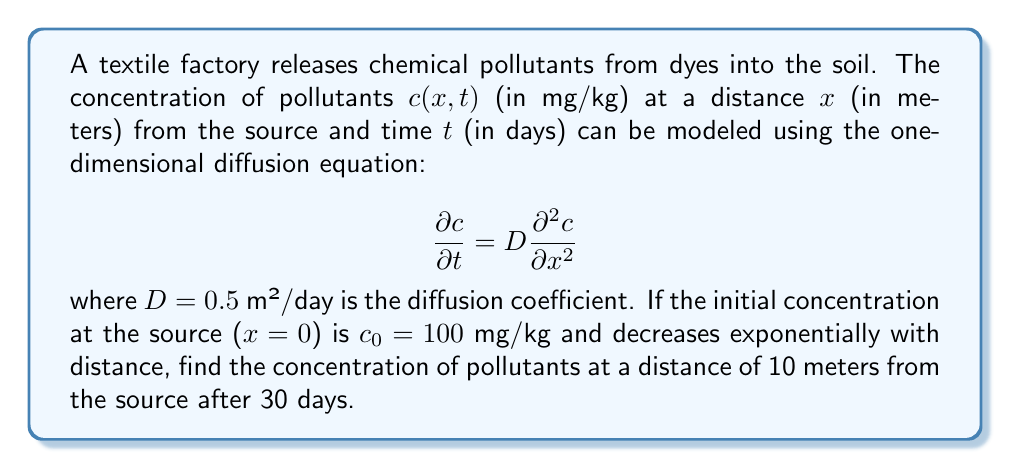Teach me how to tackle this problem. To solve this problem, we'll use the fundamental solution of the one-dimensional diffusion equation, also known as the heat equation. The solution for an initial point source is given by:

$$c(x,t) = \frac{c_0}{\sqrt{4\pi Dt}} \exp\left(-\frac{x^2}{4Dt}\right)$$

where:
- $c_0$ is the initial concentration at the source
- $D$ is the diffusion coefficient
- $x$ is the distance from the source
- $t$ is the time elapsed

Given:
- $c_0 = 100$ mg/kg
- $D = 0.5$ m²/day
- $x = 10$ m
- $t = 30$ days

Let's substitute these values into the equation:

$$c(10,30) = \frac{100}{\sqrt{4\pi \cdot 0.5 \cdot 30}} \exp\left(-\frac{10^2}{4 \cdot 0.5 \cdot 30}\right)$$

Simplifying:

$$c(10,30) = \frac{100}{\sqrt{60\pi}} \exp\left(-\frac{100}{60}\right)$$

$$c(10,30) = \frac{100}{\sqrt{60\pi}} \exp(-1.667)$$

$$c(10,30) = \frac{100}{\sqrt{60\pi}} \cdot 0.189$$

$$c(10,30) = \frac{18.9}{\sqrt{60\pi}}$$

$$c(10,30) \approx 1.37 \text{ mg/kg}$$

Therefore, the concentration of pollutants at a distance of 10 meters from the source after 30 days is approximately 1.37 mg/kg.
Answer: 1.37 mg/kg 